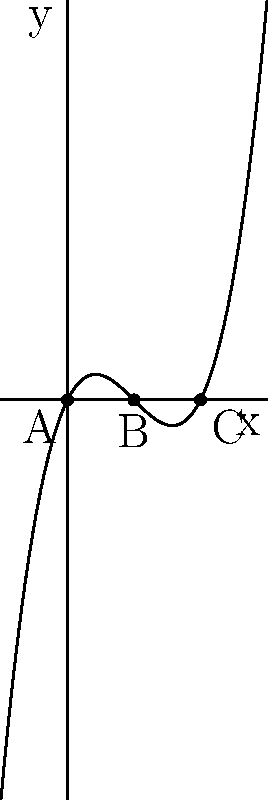Consider the polynomial function $f(x) = x^3 - 3x^2 + 2x$, which represents the character development in a novel. The roots of this polynomial correspond to key turning points in the protagonist's arc. If point A represents the beginning of the story, point C the climax, and point B a midpoint revelation, what is the sum of the x-coordinates of these three points, and how might this relate to the balanced structure of a well-crafted narrative? To solve this problem, we'll follow these steps:

1) First, we need to identify the roots of the polynomial. From the graph, we can see that the roots are at x = 0, x = 1, and x = 2.

2) These roots correspond to points A (0,0), B (1,0), and C (2,0) on the x-axis.

3) The sum of the x-coordinates is therefore:
   $0 + 1 + 2 = 3$

4) In terms of narrative structure, this sum of 3 is significant:

   a) It represents a balanced three-act structure common in storytelling.
   
   b) The equal spacing between the roots (0, 1, 2) suggests a well-paced narrative with evenly distributed turning points.
   
   c) The sum being 3 also mirrors the degree of the polynomial, which could symbolize the complexity of the character arc matching the complexity of the plot structure.

5) The fact that the roots are all real and distinct indicates clear, separate turning points in the story, avoiding narrative confusion or redundancy.

6) The shape of the polynomial (starting at 0, dipping below, then rising above) could represent the classic hero's journey: starting at equilibrium, facing challenges (negative y-values), then rising to overcome them.
Answer: 3; balanced three-act structure with evenly distributed turning points 